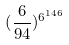Convert formula to latex. <formula><loc_0><loc_0><loc_500><loc_500>( \frac { 6 } { 9 4 } ) ^ { 6 ^ { 1 4 6 } }</formula> 